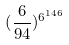Convert formula to latex. <formula><loc_0><loc_0><loc_500><loc_500>( \frac { 6 } { 9 4 } ) ^ { 6 ^ { 1 4 6 } }</formula> 